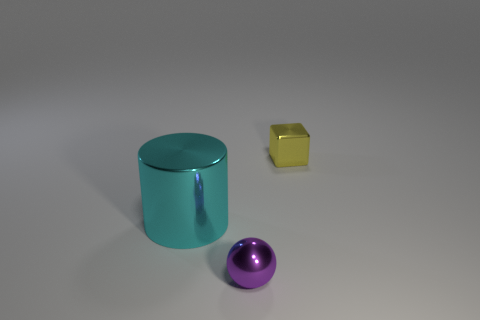Subtract all blue cubes. Subtract all blue spheres. How many cubes are left? 1 Add 2 large purple things. How many objects exist? 5 Subtract all balls. How many objects are left? 2 Subtract 0 green blocks. How many objects are left? 3 Subtract all large things. Subtract all cylinders. How many objects are left? 1 Add 3 purple metallic things. How many purple metallic things are left? 4 Add 1 tiny blue rubber things. How many tiny blue rubber things exist? 1 